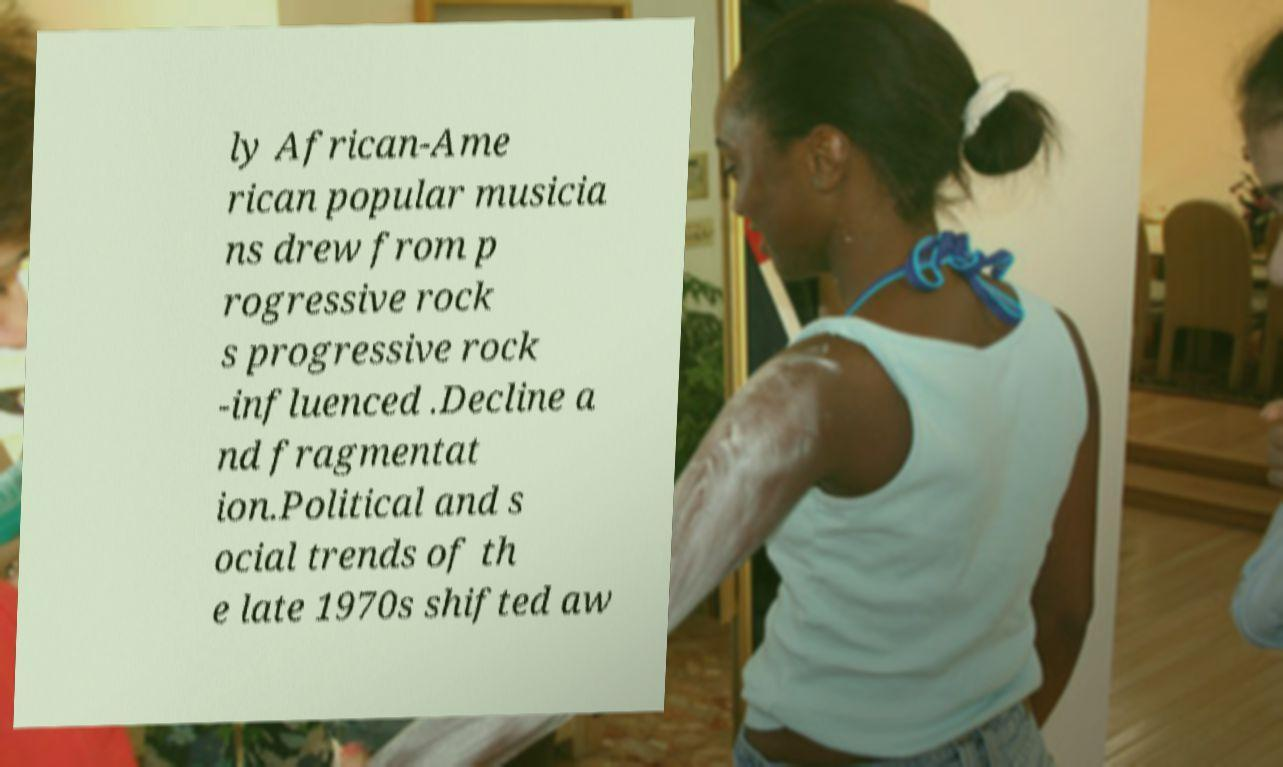For documentation purposes, I need the text within this image transcribed. Could you provide that? ly African-Ame rican popular musicia ns drew from p rogressive rock s progressive rock -influenced .Decline a nd fragmentat ion.Political and s ocial trends of th e late 1970s shifted aw 